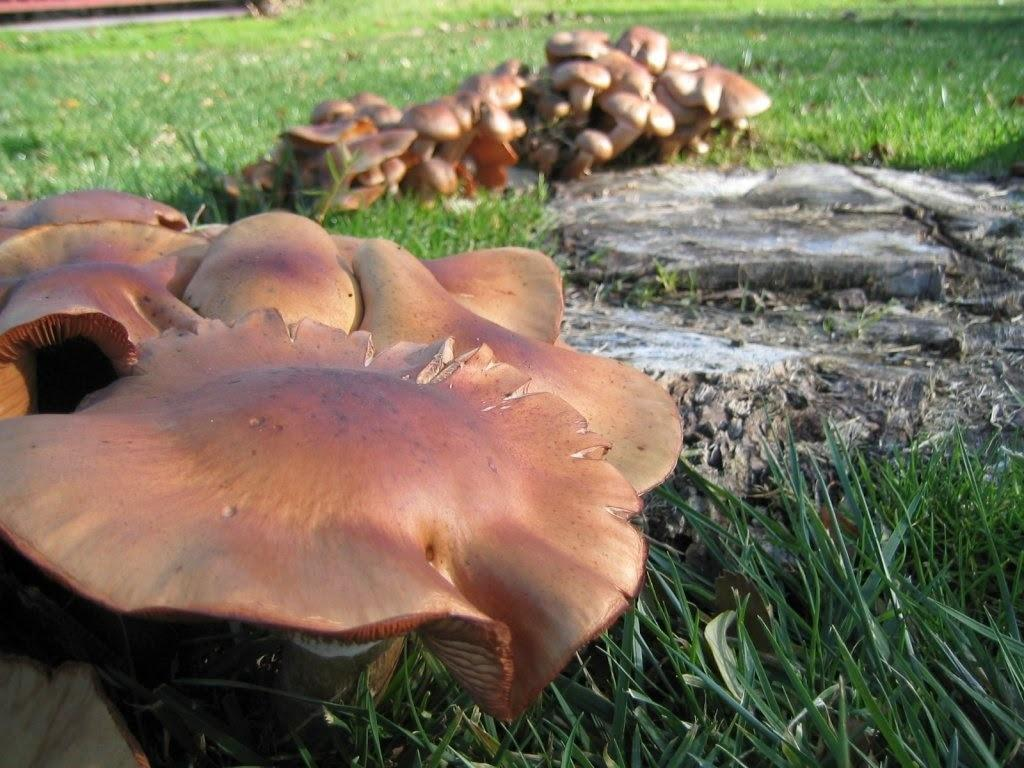What type of fungi can be seen in the image? There are mushrooms in the image. Where are the mushrooms located? The mushrooms are in a grassland. What type of record is being played at the protest in the image? There is no record or protest present in the image; it features mushrooms in a grassland. What type of mine is visible in the image? There is no mine present in the image; it features mushrooms in a grassland. 